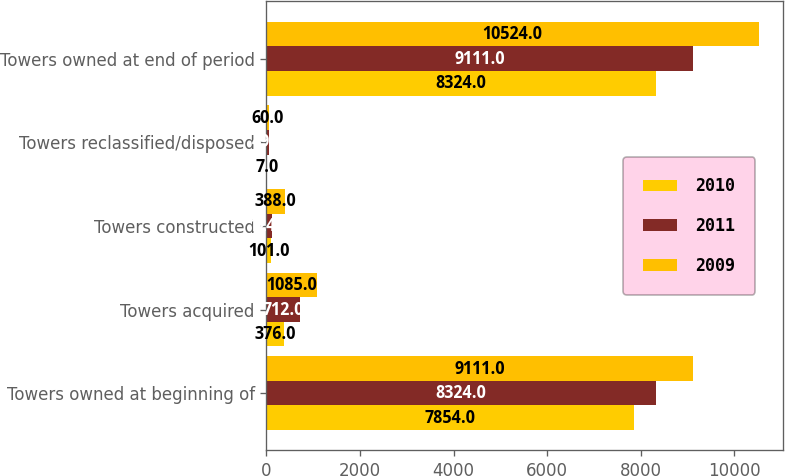Convert chart to OTSL. <chart><loc_0><loc_0><loc_500><loc_500><stacked_bar_chart><ecel><fcel>Towers owned at beginning of<fcel>Towers acquired<fcel>Towers constructed<fcel>Towers reclassified/disposed<fcel>Towers owned at end of period<nl><fcel>2010<fcel>7854<fcel>376<fcel>101<fcel>7<fcel>8324<nl><fcel>2011<fcel>8324<fcel>712<fcel>124<fcel>49<fcel>9111<nl><fcel>2009<fcel>9111<fcel>1085<fcel>388<fcel>60<fcel>10524<nl></chart> 